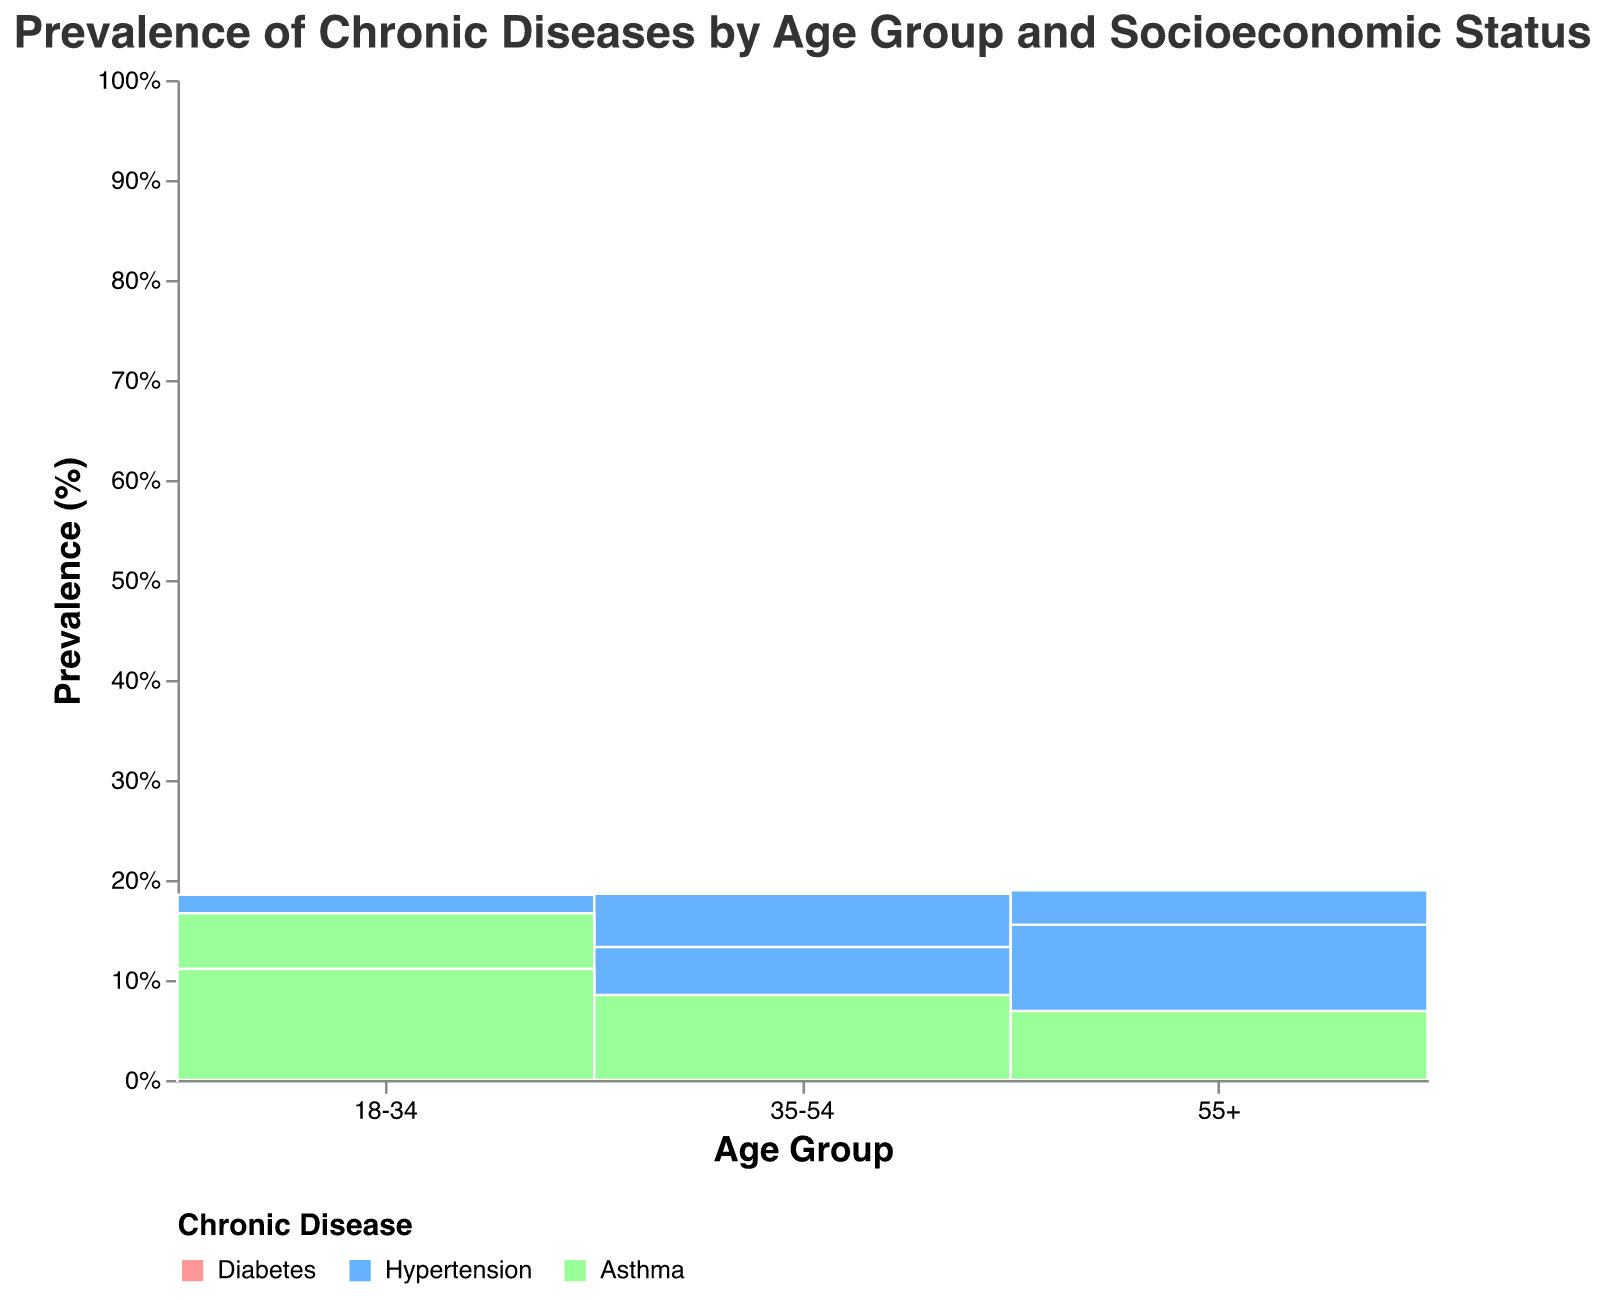What is the total prevalence of diabetes in the 55+ age group? To find this, look at the prevalence of diabetes for each socioeconomic status in the 55+ age group and sum them: 40 (Low Income) + 30 (Middle Income) + 22 (High Income) = 92 percent.
Answer: 92% Which age group has the highest prevalence of hypertension in the Low Income bracket? Examine the height of the bars for hypertension within the Low Income category across all age groups. The 55+ age group has the highest bar, indicating a prevalence of 55 percent.
Answer: 55+ In the 35-54 age group, how much higher is the prevalence of asthma in Low Income compared to High Income? In the 35-54 age group, the prevalence of asthma is 22 percent in Low Income and 14 percent in High Income. Calculate the difference: 22% - 14% = 8%.
Answer: 8% What's the overall trend in diabetes prevalence as age increases, regardless of socioeconomic status? Read the prevalence data for each age group: It is low in the 18-34 age group, increases in the 35-54 age group, and is highest in the 55+ age group. This indicates an increasing trend with age.
Answer: Increasing For middle-income individuals, which chronic disease has the lowest prevalence in the 18-34 age group? Compare the prevalence bars of all chronic diseases in the Middle Income category for the 18-34 age group. Diabetes has the lowest prevalence, with 8 percent.
Answer: Diabetes Is asthma more prevalent among high-income individuals in the 55+ age group than in the 18-34 age group? Look at asthma bars for High Income individuals in both age groups. In the 55+ group, the prevalence is 18 percent, while in the 18-34 group, it is 10 percent. Compare them to see that asthma is more prevalent in the 55+ age group.
Answer: Yes How does the prevalence of hypertension in the Middle Income group change from the 18-34 age group to the 55+ age group? Examine the hypertension prevalence bars for Middle Income from the 18-34 age group (12 percent), 35-54 age group (25 percent), and 55+ age group (45 percent). The prevalence increases as age increases.
Answer: Increases Which socioeconomic status has the largest difference in diabetes prevalence between the 35-54 age group and the 55+ age group? Calculate the difference for each socioeconomic status: 
- Low Income: 40% - 28% = 12%
- Middle Income: 30% - 18% = 12%
- High Income: 22% - 12% = 10%
Both Low Income and Middle Income have the largest difference of 12 percent.
Answer: Low Income and Middle Income In which age group is the prevalence of asthma consistently the highest across all socioeconomic statuses? Compare the prevalence bars for asthma across all age groups and socioeconomic statuses. The 55+ age group consistently has the highest prevalence: Low Income (25%), Middle Income (20%), High Income (18%).
Answer: 55+ 